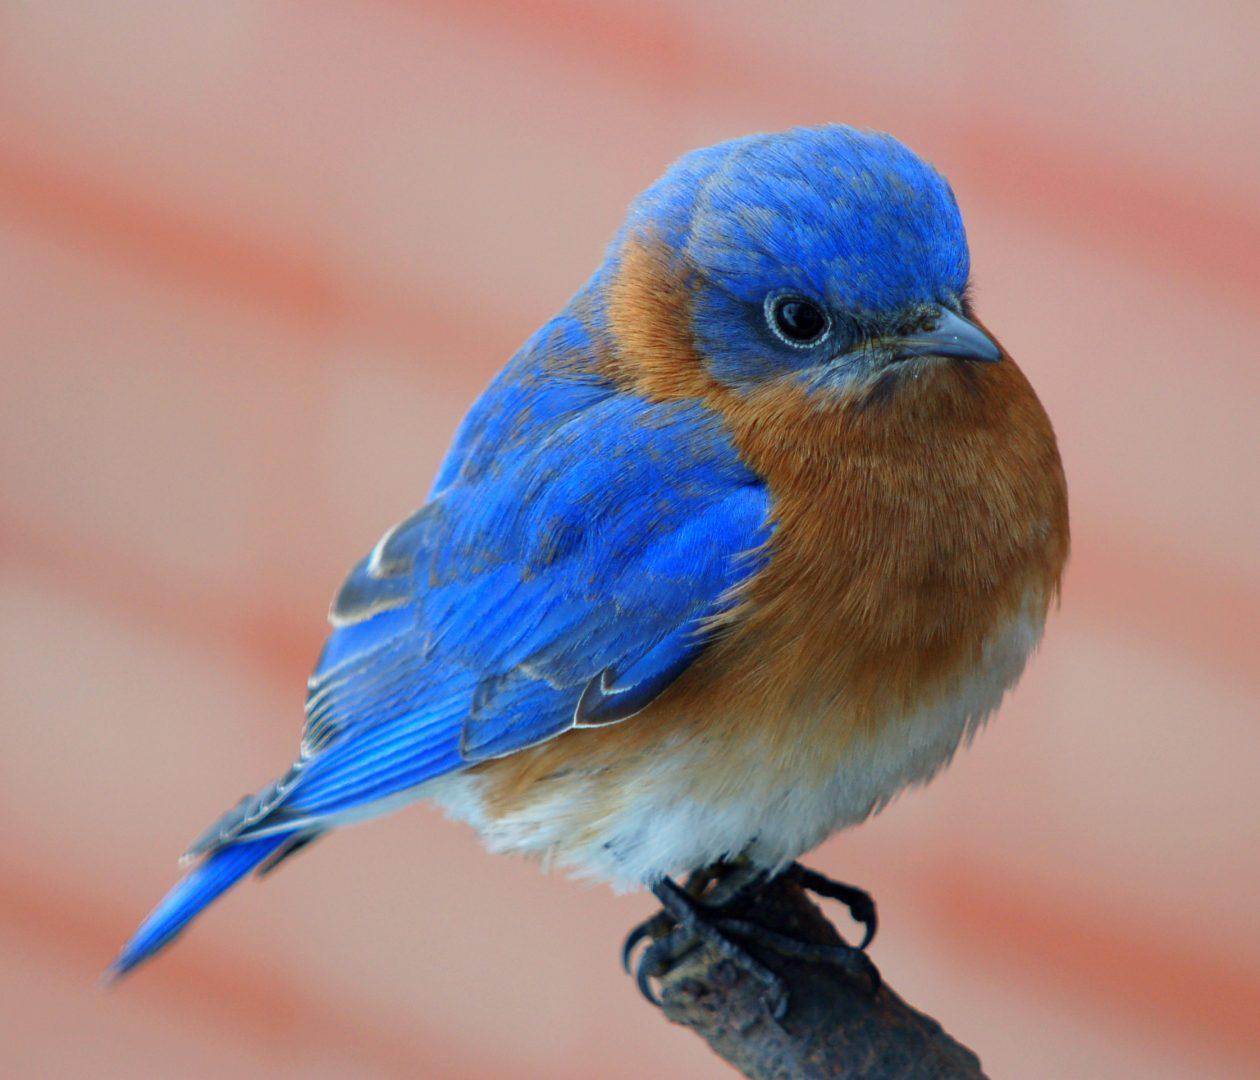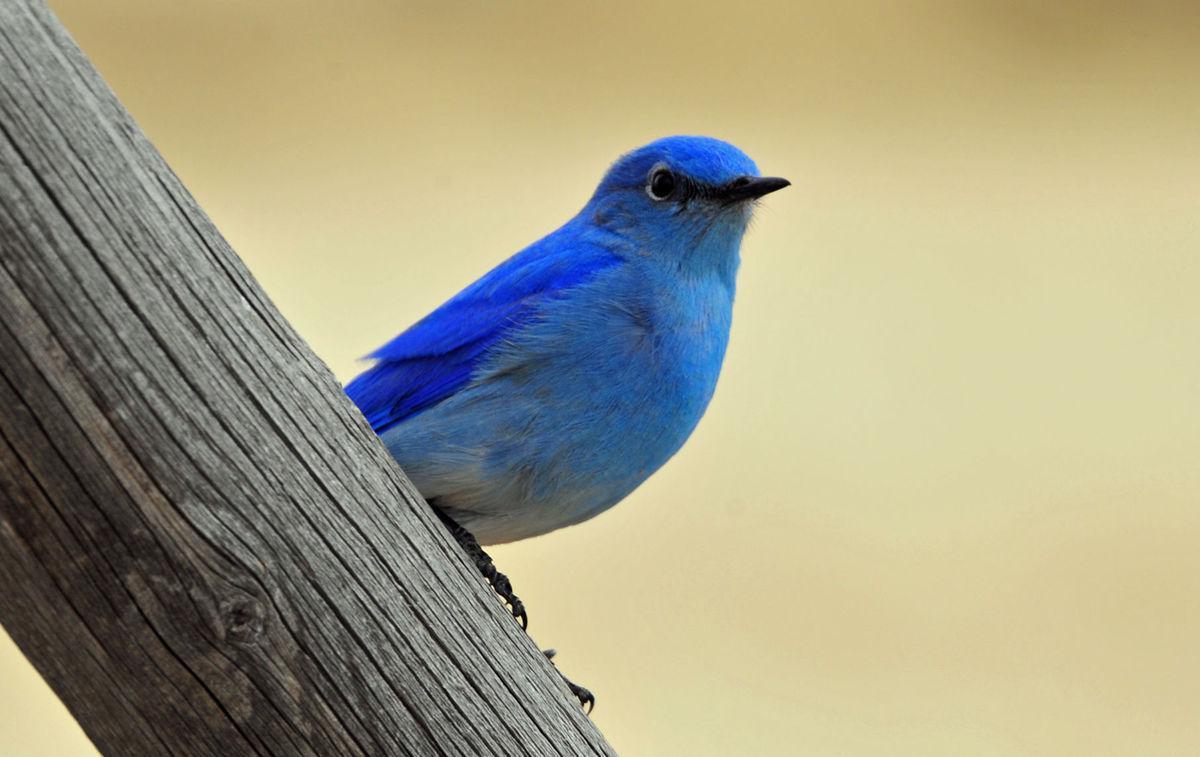The first image is the image on the left, the second image is the image on the right. Considering the images on both sides, is "In at least one image, a single bird is pictured that lacks a yellow ring around the eye and has a small straight beak." valid? Answer yes or no. Yes. The first image is the image on the left, the second image is the image on the right. Given the left and right images, does the statement "All images show a blue-feathered bird perched on something resembling wood." hold true? Answer yes or no. Yes. 